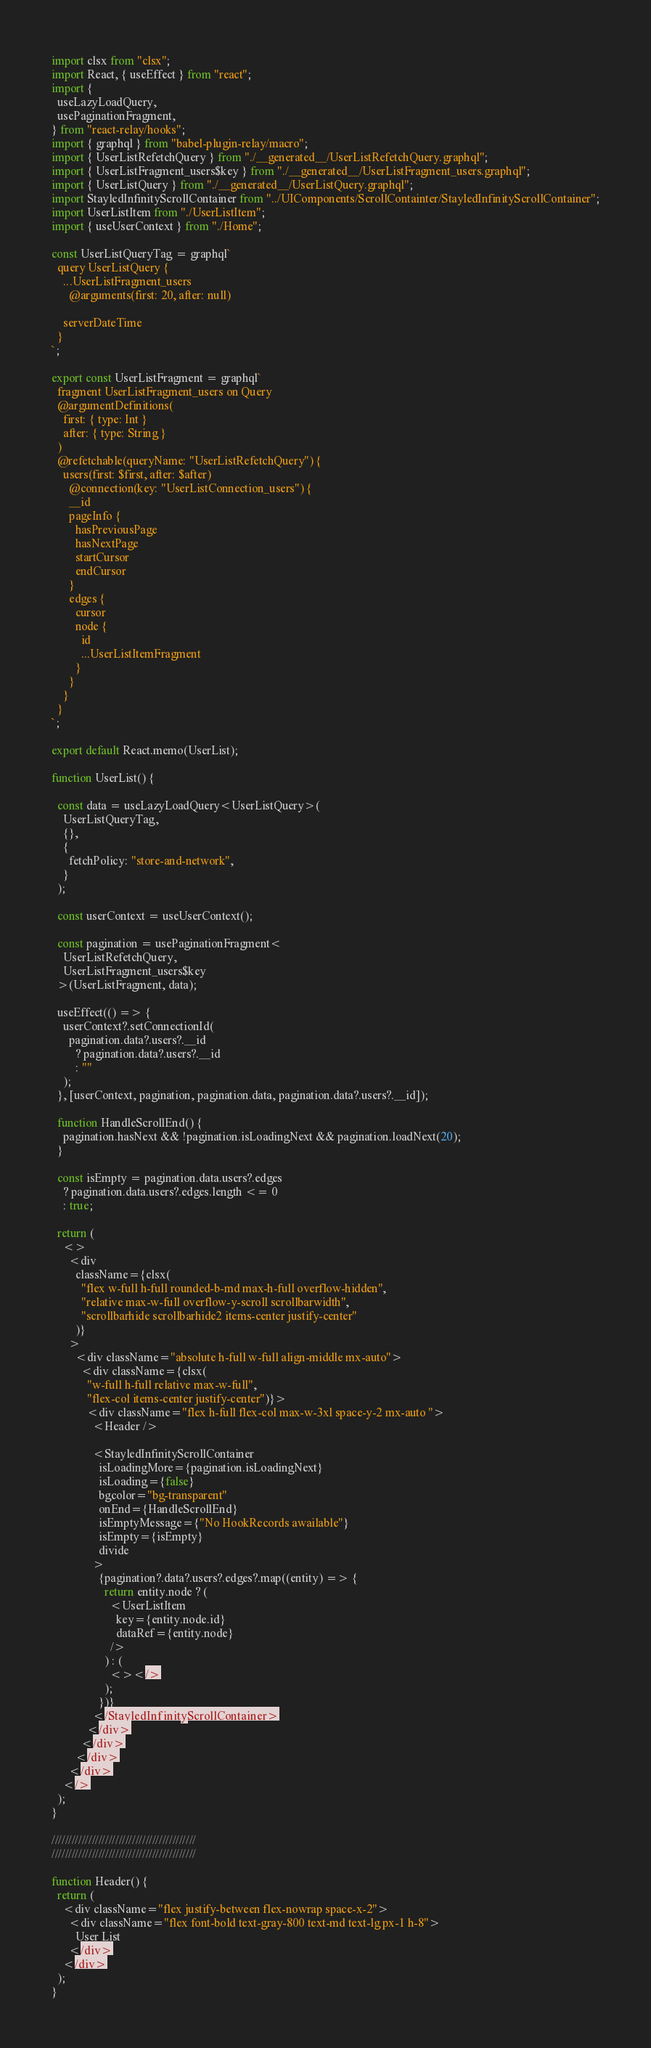Convert code to text. <code><loc_0><loc_0><loc_500><loc_500><_TypeScript_>import clsx from "clsx";
import React, { useEffect } from "react";
import {
  useLazyLoadQuery,
  usePaginationFragment,
} from "react-relay/hooks";
import { graphql } from "babel-plugin-relay/macro";
import { UserListRefetchQuery } from "./__generated__/UserListRefetchQuery.graphql";
import { UserListFragment_users$key } from "./__generated__/UserListFragment_users.graphql";
import { UserListQuery } from "./__generated__/UserListQuery.graphql";
import StayledInfinityScrollContainer from "../UIComponents/ScrollContainter/StayledInfinityScrollContainer";
import UserListItem from "./UserListItem";
import { useUserContext } from "./Home";

const UserListQueryTag = graphql`
  query UserListQuery {
    ...UserListFragment_users
      @arguments(first: 20, after: null)

    serverDateTime
  }
`;

export const UserListFragment = graphql`
  fragment UserListFragment_users on Query
  @argumentDefinitions(
    first: { type: Int }
    after: { type: String }
  )
  @refetchable(queryName: "UserListRefetchQuery") {
    users(first: $first, after: $after)
      @connection(key: "UserListConnection_users") {
      __id
      pageInfo {
        hasPreviousPage
        hasNextPage
        startCursor
        endCursor
      }
      edges {
        cursor
        node {
          id
          ...UserListItemFragment
        }
      }
    }
  }
`;

export default React.memo(UserList);

function UserList() {

  const data = useLazyLoadQuery<UserListQuery>(
    UserListQueryTag,
    {},
    {
      fetchPolicy: "store-and-network",
    }
  );

  const userContext = useUserContext();

  const pagination = usePaginationFragment<
    UserListRefetchQuery,
    UserListFragment_users$key
  >(UserListFragment, data);

  useEffect(() => {
    userContext?.setConnectionId(
      pagination.data?.users?.__id
        ? pagination.data?.users?.__id
        : ""
    );
  }, [userContext, pagination, pagination.data, pagination.data?.users?.__id]);

  function HandleScrollEnd() {
    pagination.hasNext && !pagination.isLoadingNext && pagination.loadNext(20);
  }

  const isEmpty = pagination.data.users?.edges
    ? pagination.data.users?.edges.length <= 0
    : true;

  return (
    <>
      <div
        className={clsx(
          "flex w-full h-full rounded-b-md max-h-full overflow-hidden",
          "relative max-w-full overflow-y-scroll scrollbarwidth",
          "scrollbarhide scrollbarhide2 items-center justify-center"
        )}
      >
        <div className="absolute h-full w-full align-middle mx-auto">
          <div className={clsx(
            "w-full h-full relative max-w-full",
            "flex-col items-center justify-center")}>
            <div className="flex h-full flex-col max-w-3xl space-y-2 mx-auto ">
              <Header />

              <StayledInfinityScrollContainer
                isLoadingMore={pagination.isLoadingNext}
                isLoading={false}
                bgcolor="bg-transparent"
                onEnd={HandleScrollEnd}
                isEmptyMessage={"No HookRecords awailable"}
                isEmpty={isEmpty}
                divide
              >
                {pagination?.data?.users?.edges?.map((entity) => {
                  return entity.node ? (
                    <UserListItem
                      key={entity.node.id}
                      dataRef={entity.node}
                    />
                  ) : (
                    <></>
                  );
                })}
              </StayledInfinityScrollContainer>
            </div>
          </div>
        </div>
      </div>
    </>
  );
}

///////////////////////////////////////////
///////////////////////////////////////////

function Header() {
  return (
    <div className="flex justify-between flex-nowrap space-x-2">
      <div className="flex font-bold text-gray-800 text-md text-lg px-1 h-8">
        User List
      </div>
    </div>
  );
}
</code> 